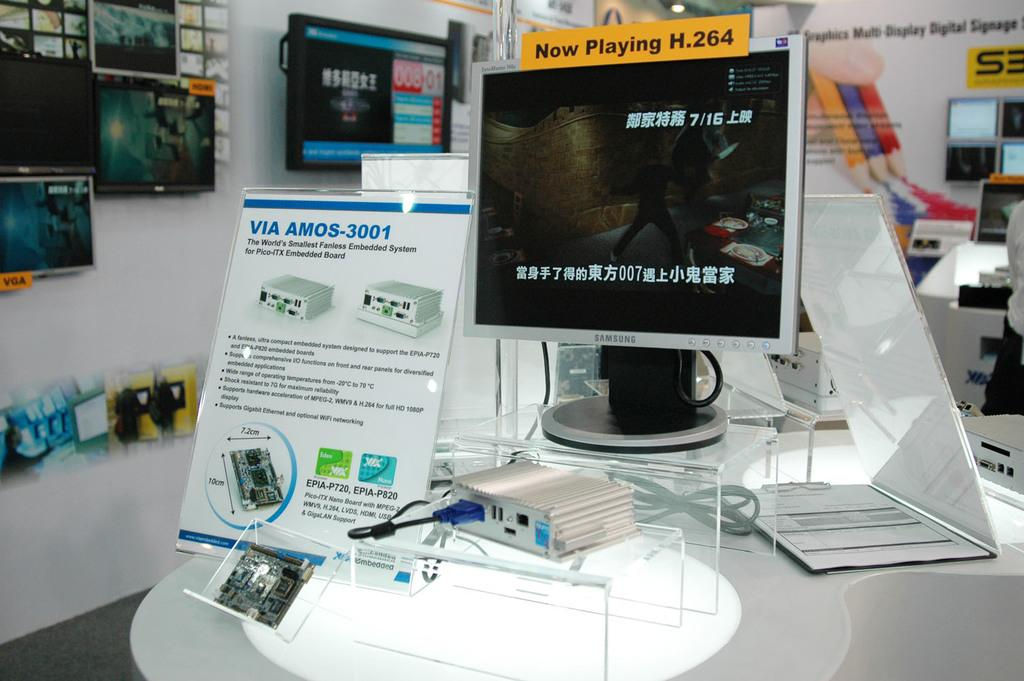<image>
Present a compact description of the photo's key features. The monitor has a sticker which reads Now Playing 